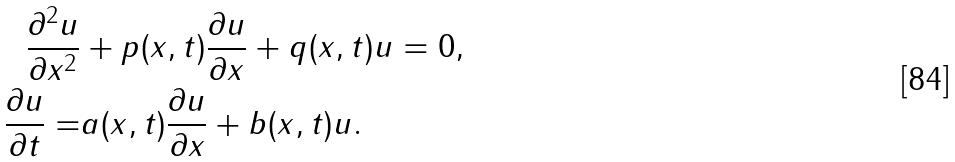Convert formula to latex. <formula><loc_0><loc_0><loc_500><loc_500>\frac { \partial ^ { 2 } u } { \partial x ^ { 2 } } & + p ( x , t ) \frac { \partial u } { \partial x } + q ( x , t ) u = 0 , \\ \frac { \partial u } { \partial t } = & a ( x , t ) \frac { \partial u } { \partial x } + b ( x , t ) u .</formula> 